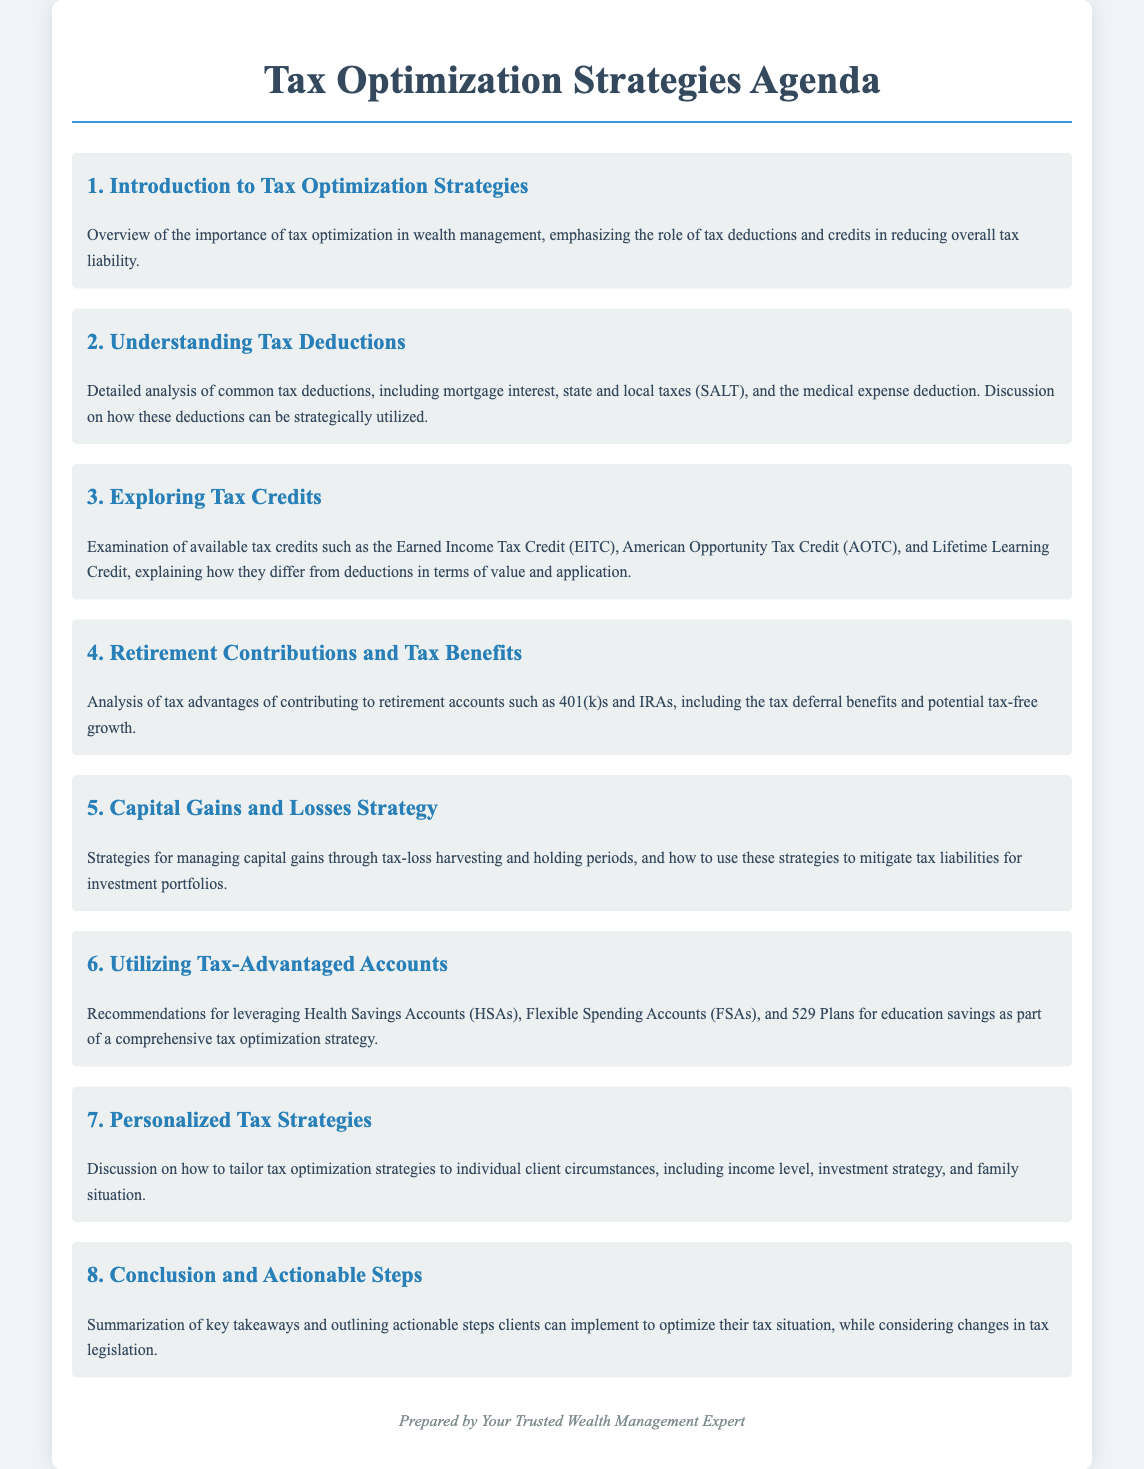What is the title of the document? The title of the document is stated at the top of the agenda section, which is "Tax Optimization Strategies Agenda."
Answer: Tax Optimization Strategies Agenda How many main agenda items are listed? The document counts the main agenda items from 1 to 8, totaling 8 items.
Answer: 8 What is the focus of agenda item 2? Agenda item 2 centers around tax deductions and analyzes various types commonly used for reducing tax liability.
Answer: Understanding Tax Deductions Which tax credit is mentioned as the first in agenda item 3? The first tax credit discussed in agenda item 3 is the Earned Income Tax Credit (EITC).
Answer: Earned Income Tax Credit (EITC) What is one type of account recommended for tax advantages in agenda item 6? One type of account recommended is the Health Savings Accounts (HSAs) for tax optimization strategies.
Answer: Health Savings Accounts (HSAs) What personalized element is discussed in agenda item 7? Agenda item 7 emphasizes tailoring tax optimization strategies to individual client circumstances.
Answer: Individual client circumstances What is summarized in agenda item 8? Agenda item 8 summarizes key takeaways and outlines actionable steps for clients to optimize their tax situation.
Answer: Key takeaways and actionable steps 